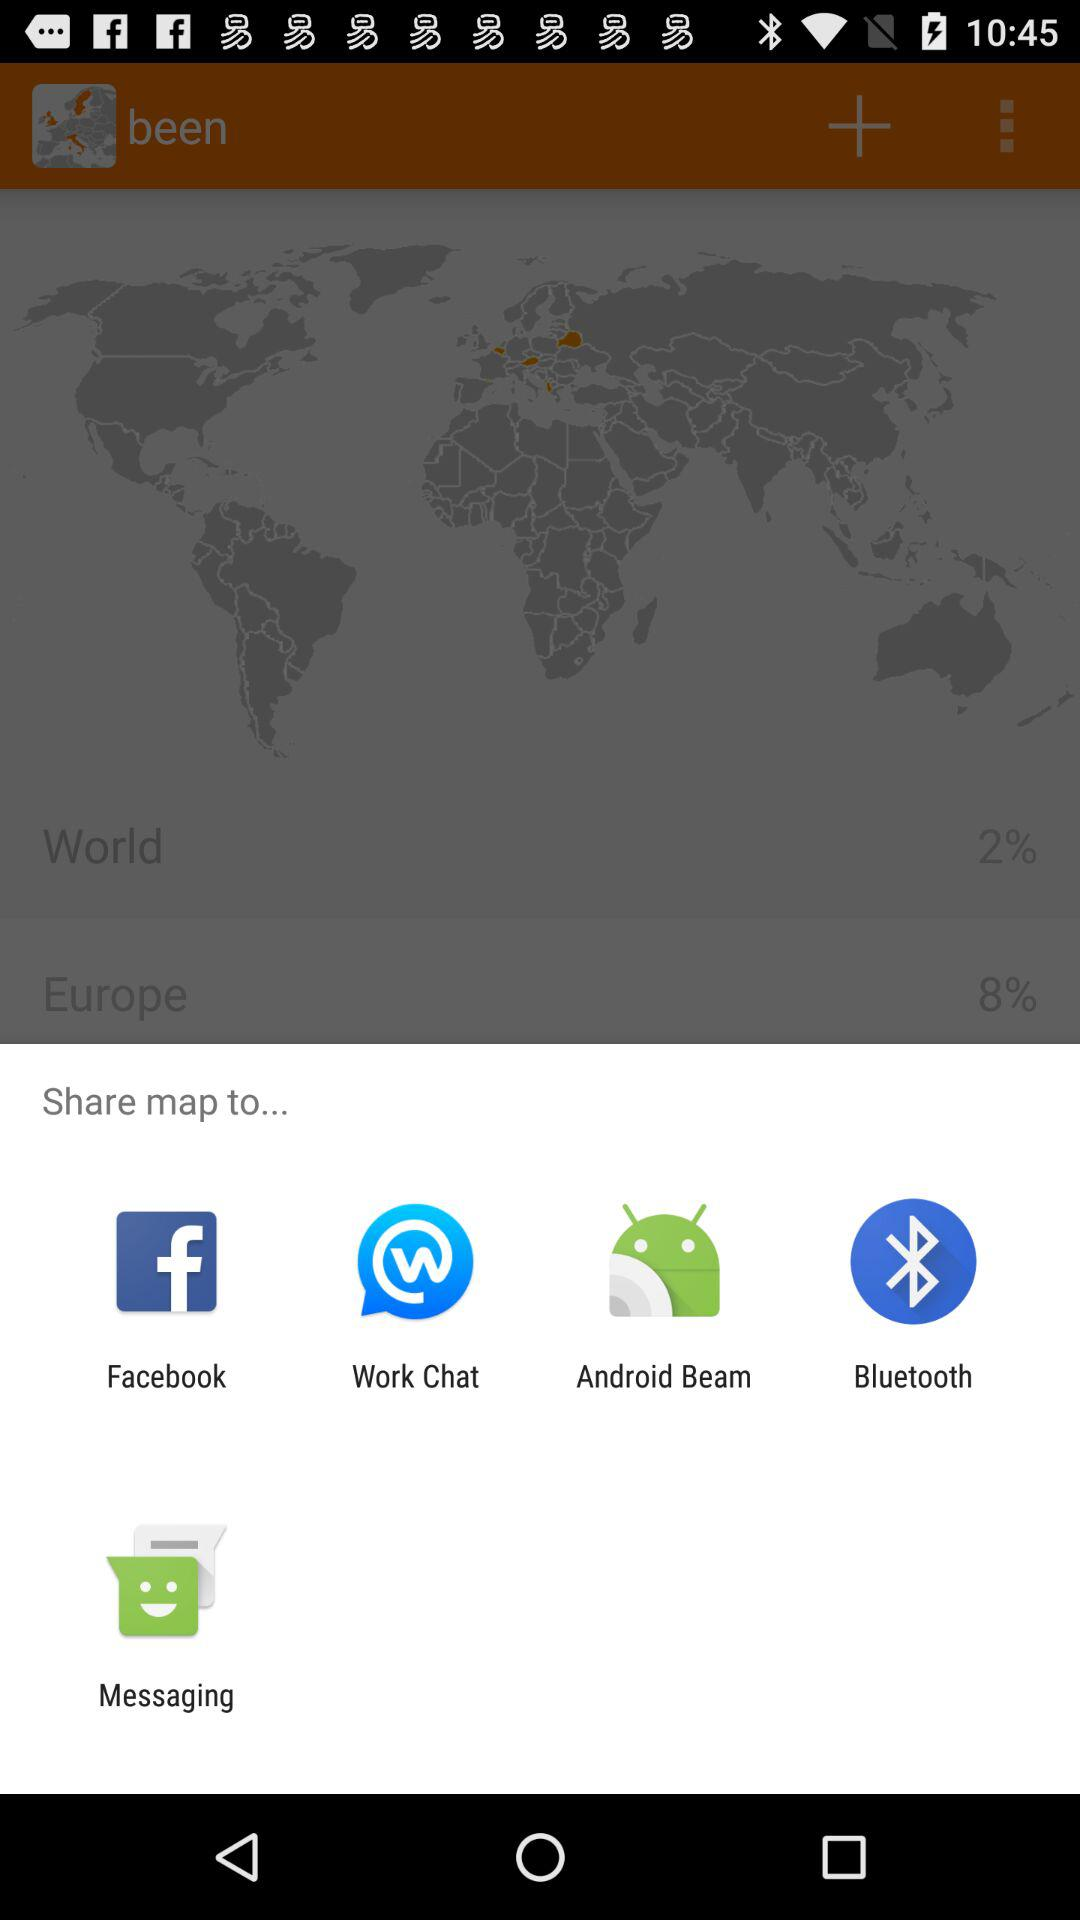What application can I use for sharing the map? You can share it with "Facebook", "Work Chat", "Android Beam", "Bluetooth" and "Messaging". 